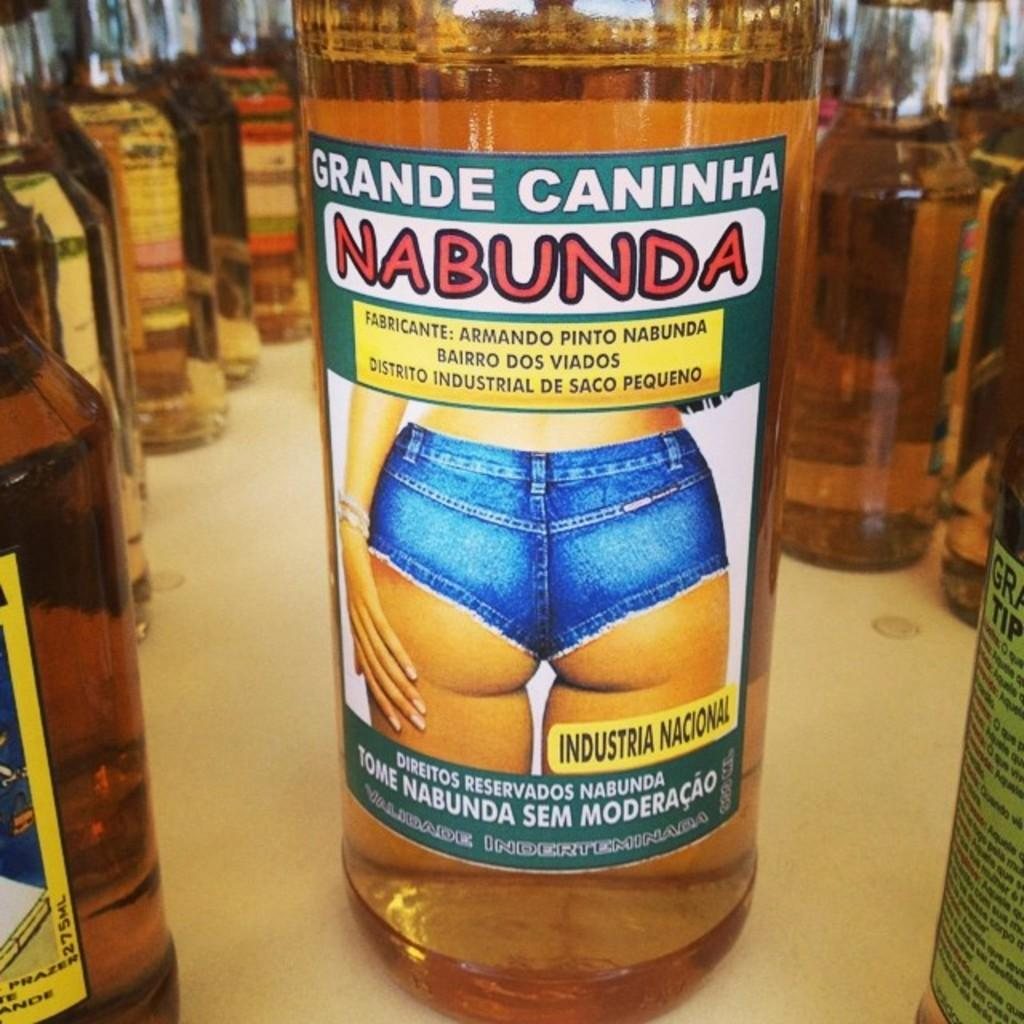What can be seen in the image? There are multiple bottles in the image. Can you identify any specific bottle in the image? Yes, there is a bottle called Nabunda in the middle of the image. Where is the rice stored in the image? There is no rice present in the image. What type of desk is visible in the image? There is no desk present in the image. 